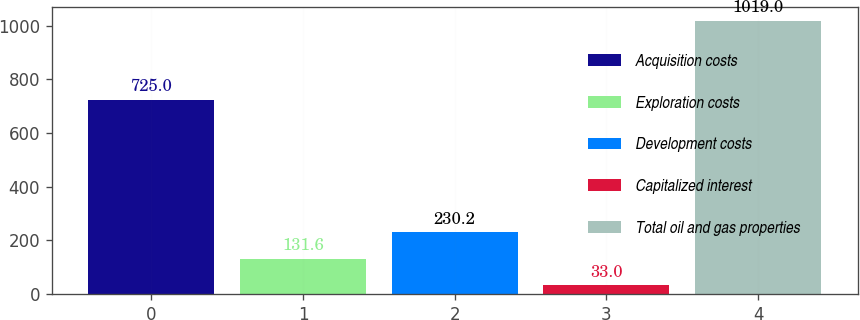<chart> <loc_0><loc_0><loc_500><loc_500><bar_chart><fcel>Acquisition costs<fcel>Exploration costs<fcel>Development costs<fcel>Capitalized interest<fcel>Total oil and gas properties<nl><fcel>725<fcel>131.6<fcel>230.2<fcel>33<fcel>1019<nl></chart> 